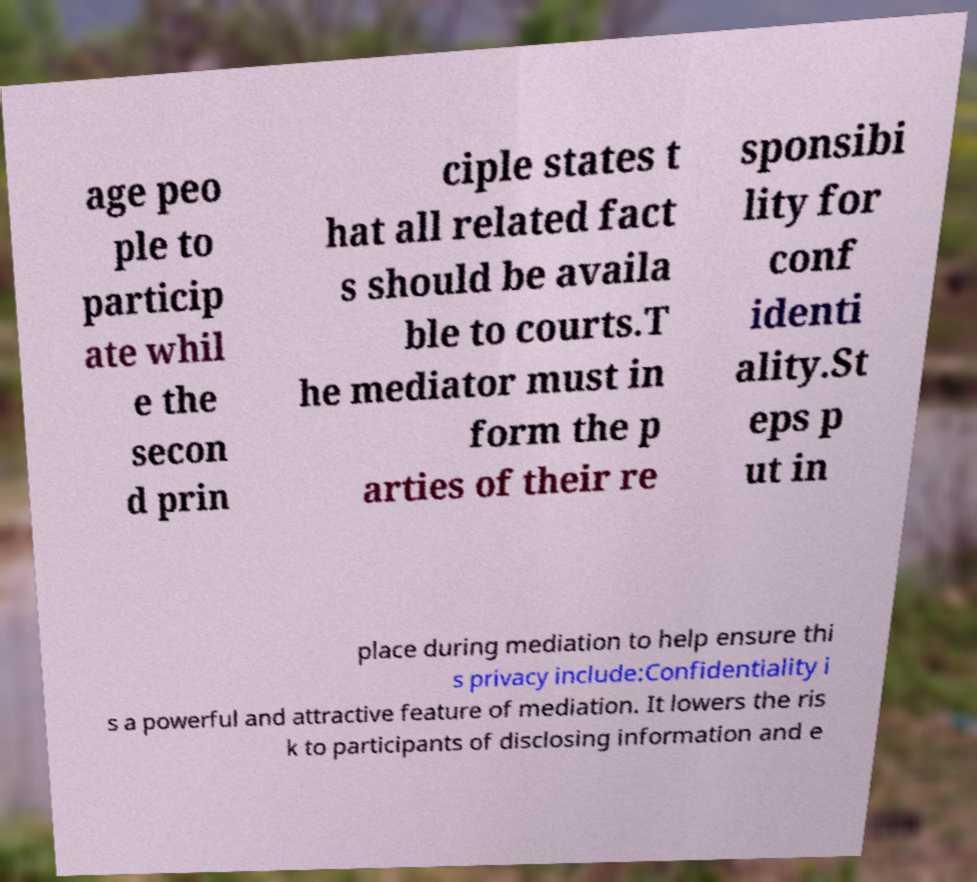Could you extract and type out the text from this image? age peo ple to particip ate whil e the secon d prin ciple states t hat all related fact s should be availa ble to courts.T he mediator must in form the p arties of their re sponsibi lity for conf identi ality.St eps p ut in place during mediation to help ensure thi s privacy include:Confidentiality i s a powerful and attractive feature of mediation. It lowers the ris k to participants of disclosing information and e 